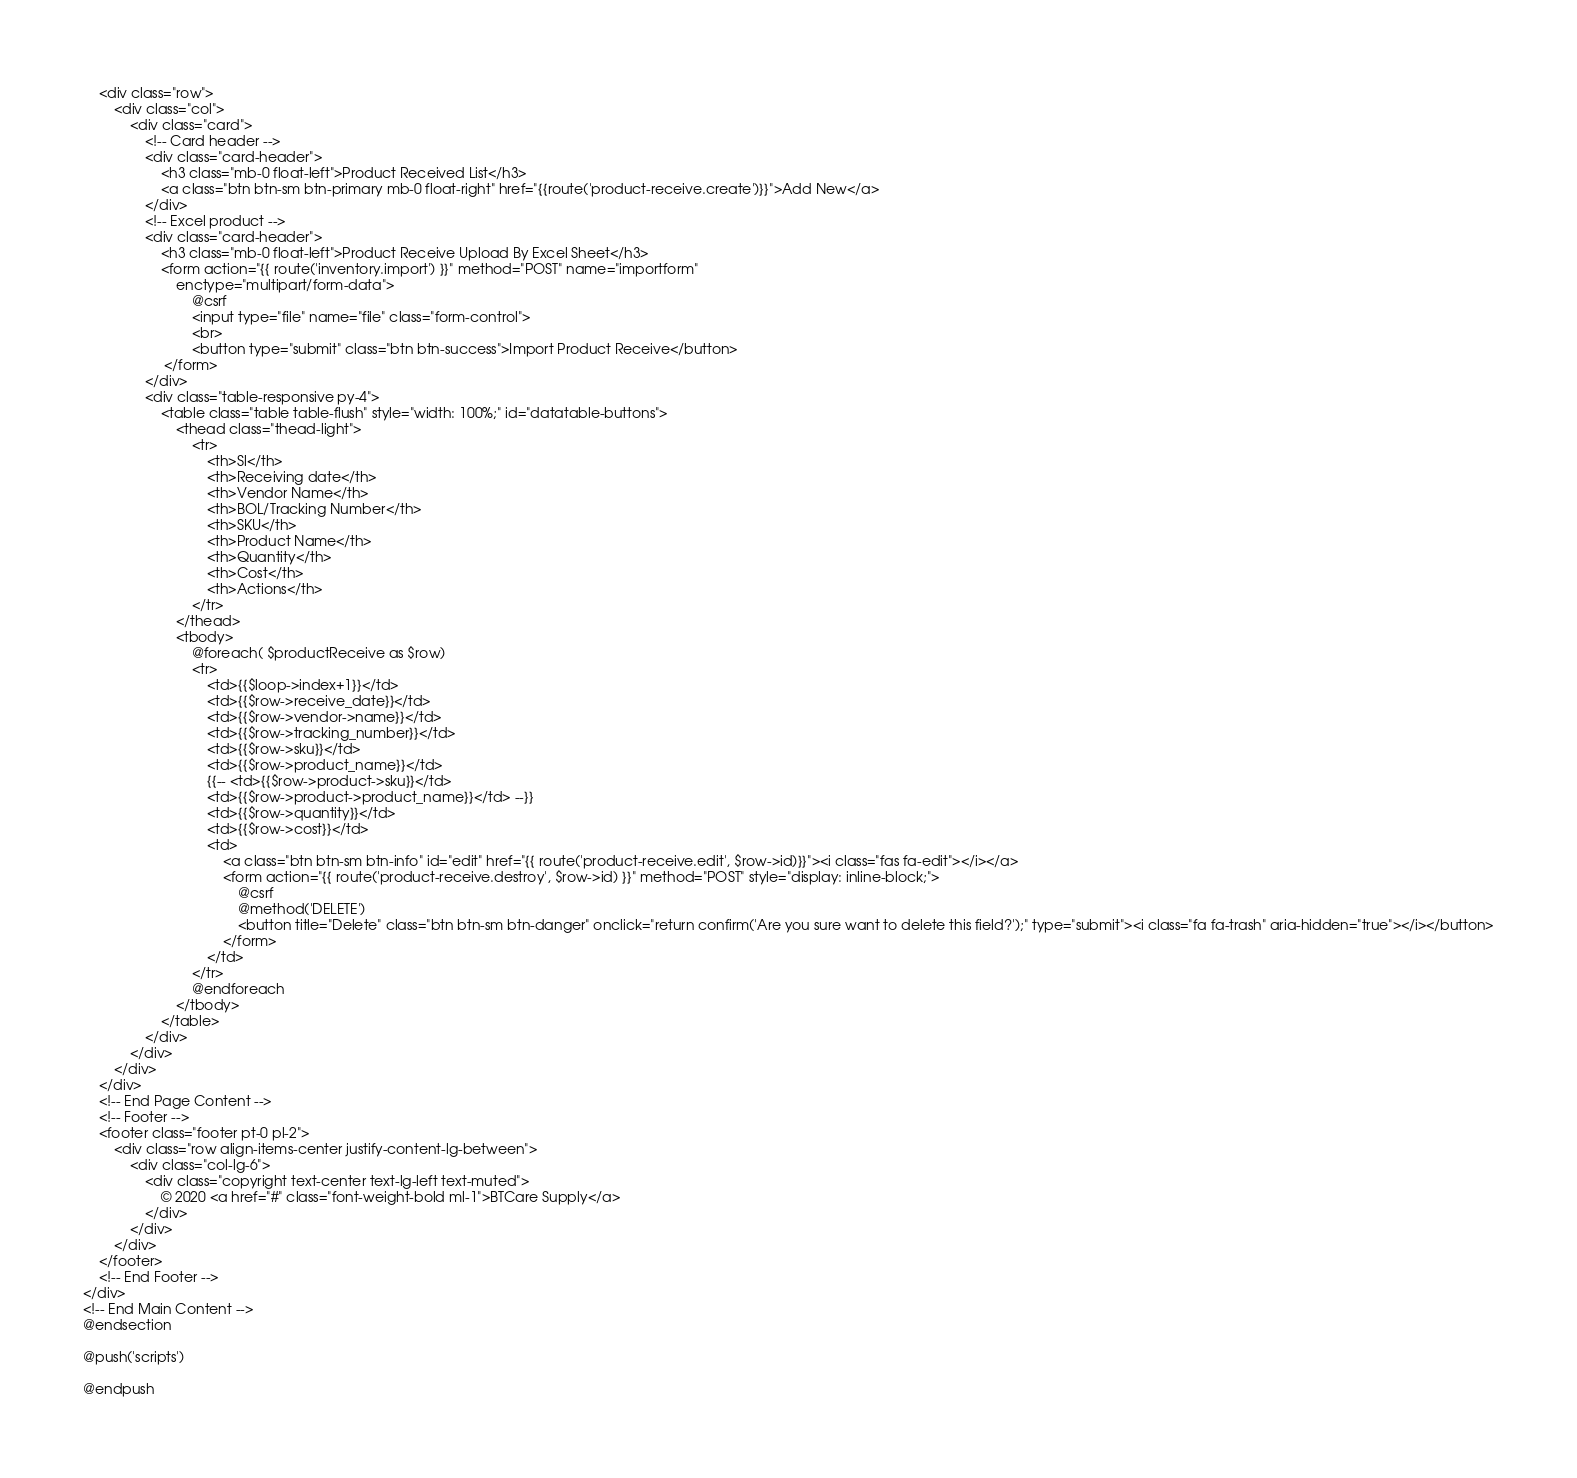<code> <loc_0><loc_0><loc_500><loc_500><_PHP_>    <div class="row">
        <div class="col">
            <div class="card">
                <!-- Card header -->
                <div class="card-header">
                    <h3 class="mb-0 float-left">Product Received List</h3>
                    <a class="btn btn-sm btn-primary mb-0 float-right" href="{{route('product-receive.create')}}">Add New</a>
                </div>
                <!-- Excel product -->
                <div class="card-header">
                    <h3 class="mb-0 float-left">Product Receive Upload By Excel Sheet</h3>
                    <form action="{{ route('inventory.import') }}" method="POST" name="importform"
                        enctype="multipart/form-data">
                            @csrf
                            <input type="file" name="file" class="form-control">
                            <br>
                            <button type="submit" class="btn btn-success">Import Product Receive</button>
                     </form>
                </div>
                <div class="table-responsive py-4">
                    <table class="table table-flush" style="width: 100%;" id="datatable-buttons">
                        <thead class="thead-light">
                            <tr>
                                <th>Sl</th>
                                <th>Receiving date</th>
                                <th>Vendor Name</th>
                                <th>BOL/Tracking Number</th>
                                <th>SKU</th>
                                <th>Product Name</th>
                                <th>Quantity</th>
                                <th>Cost</th>
                                <th>Actions</th>
                            </tr>
                        </thead>
                        <tbody>
                            @foreach( $productReceive as $row)
                            <tr>
                                <td>{{$loop->index+1}}</td>
                                <td>{{$row->receive_date}}</td>
                                <td>{{$row->vendor->name}}</td>
                                <td>{{$row->tracking_number}}</td>
                                <td>{{$row->sku}}</td>
                                <td>{{$row->product_name}}</td>
                                {{-- <td>{{$row->product->sku}}</td>
                                <td>{{$row->product->product_name}}</td> --}}
                                <td>{{$row->quantity}}</td>
                                <td>{{$row->cost}}</td>
                                <td>
                                    <a class="btn btn-sm btn-info" id="edit" href="{{ route('product-receive.edit', $row->id)}}"><i class="fas fa-edit"></i></a>
                                    <form action="{{ route('product-receive.destroy', $row->id) }}" method="POST" style="display: inline-block;">
                                        @csrf
                                        @method('DELETE')
                                        <button title="Delete" class="btn btn-sm btn-danger" onclick="return confirm('Are you sure want to delete this field?');" type="submit"><i class="fa fa-trash" aria-hidden="true"></i></button>
                                    </form>
                                </td>
                            </tr>
                            @endforeach
                        </tbody>
                    </table>
                </div>
            </div>
        </div>
    </div>
    <!-- End Page Content -->
    <!-- Footer -->
    <footer class="footer pt-0 pl-2">
        <div class="row align-items-center justify-content-lg-between">
            <div class="col-lg-6">
                <div class="copyright text-center text-lg-left text-muted">
                    © 2020 <a href="#" class="font-weight-bold ml-1">BTCare Supply</a>
                </div>
            </div>
        </div>
    </footer>
    <!-- End Footer -->
</div>
<!-- End Main Content -->
@endsection

@push('scripts')

@endpush</code> 